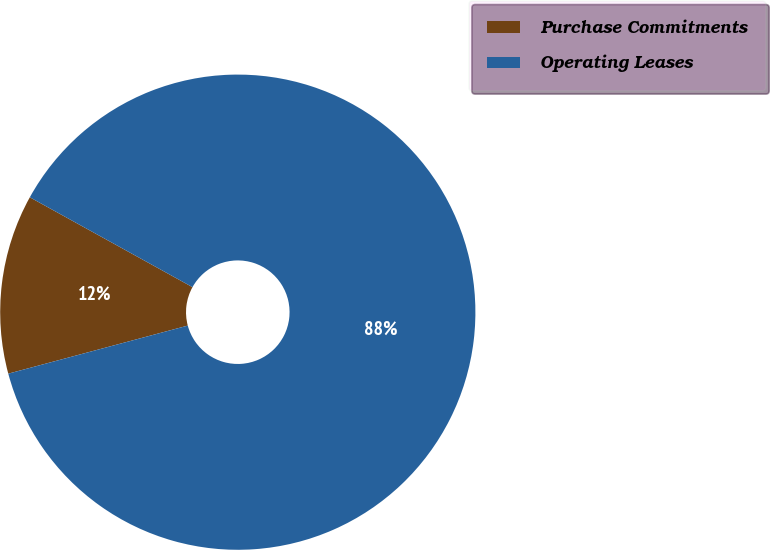Convert chart to OTSL. <chart><loc_0><loc_0><loc_500><loc_500><pie_chart><fcel>Purchase Commitments<fcel>Operating Leases<nl><fcel>12.2%<fcel>87.8%<nl></chart> 